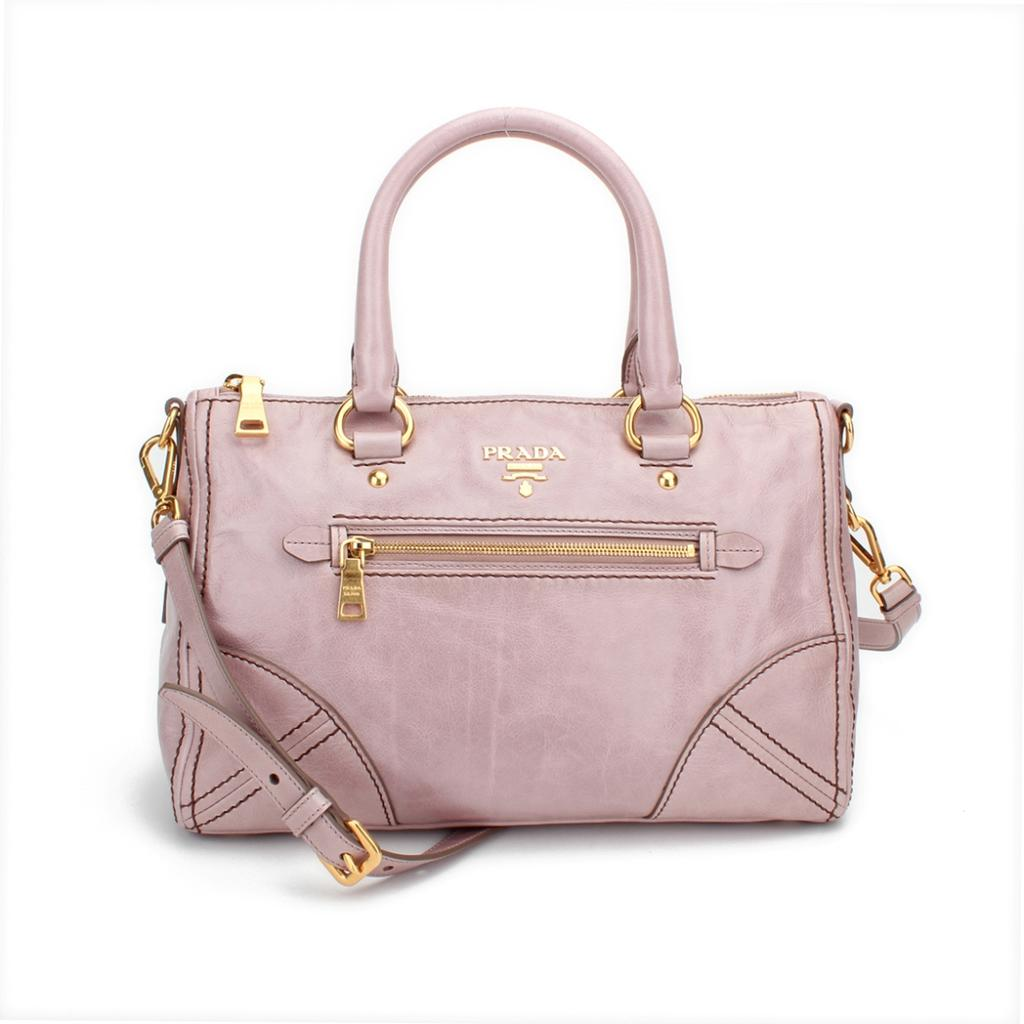What type of handbag can be seen in the image? There is a pink color handbag in the image. Are there any bushes or produce visible in the image? No, there are no bushes or produce present in the image; it only features a pink handbag. 